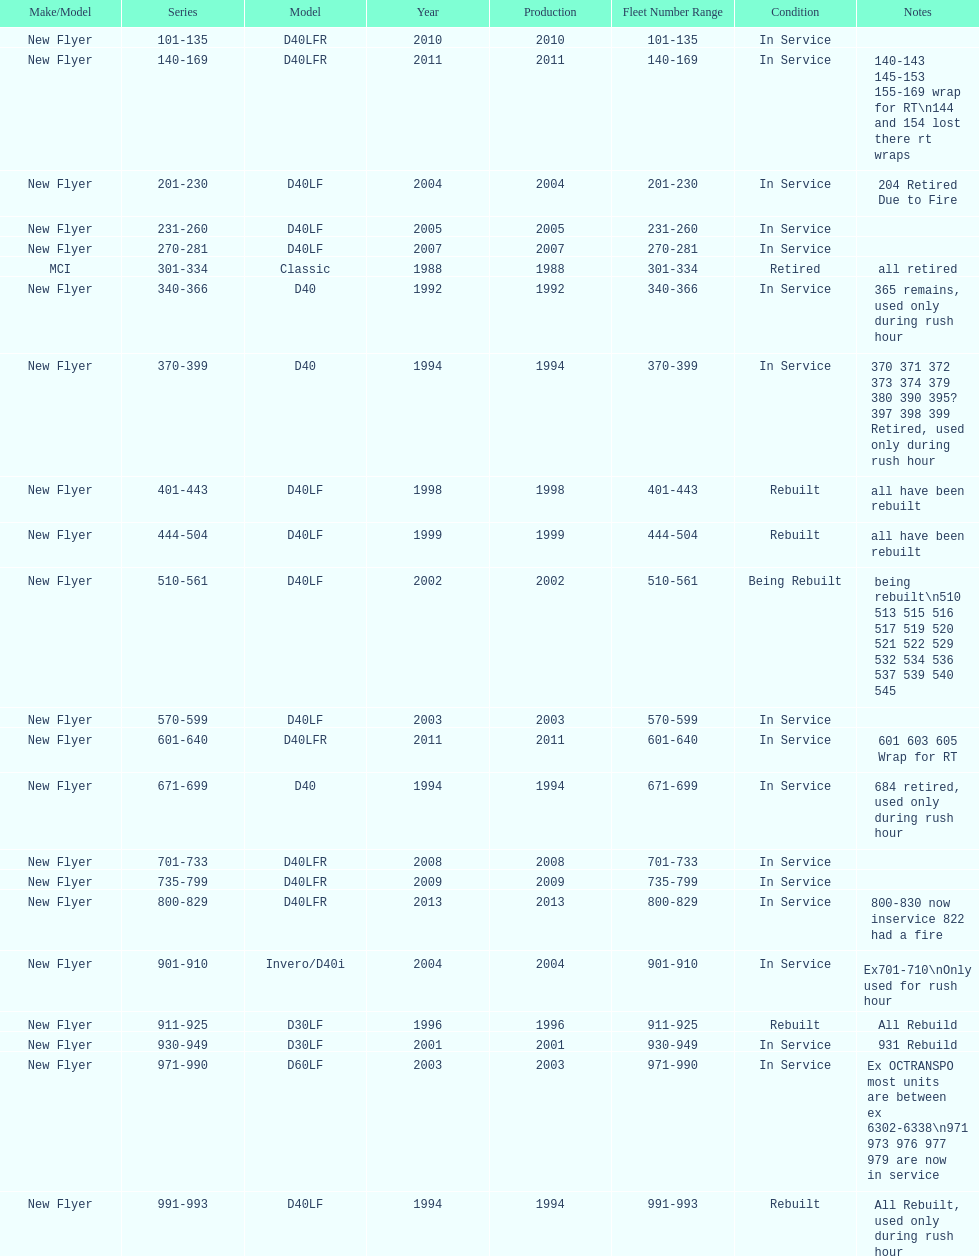Which buses are the newest in the current fleet? 800-829. 